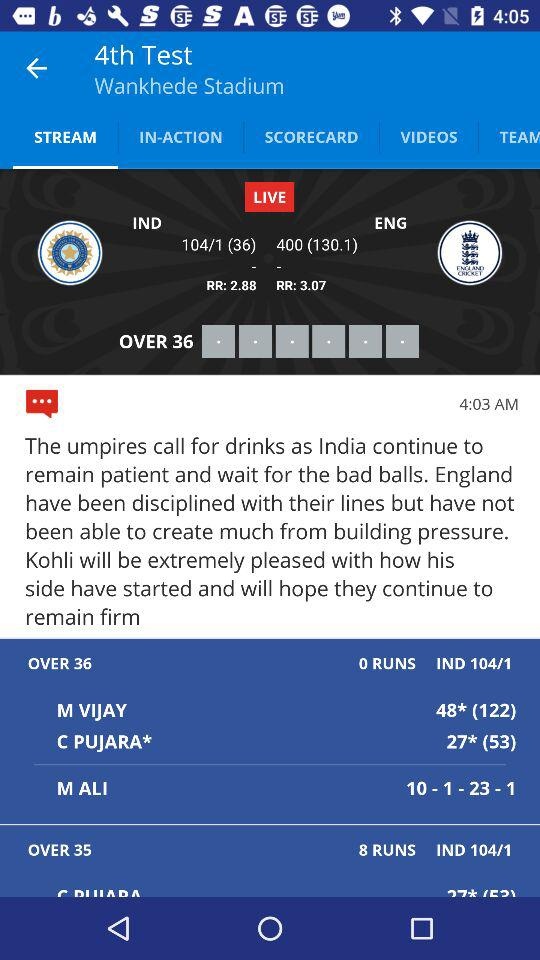What is the run rate for the current innings? The current run rate for the Indian innings is shown as 2.88 runs per over. And how does that compare to England's run rate? England's run rate was 3.07, which is slightly higher than India's current run rate. 